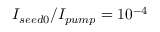<formula> <loc_0><loc_0><loc_500><loc_500>I _ { s e e d 0 } / I _ { p u m p } = 1 0 ^ { - 4 }</formula> 